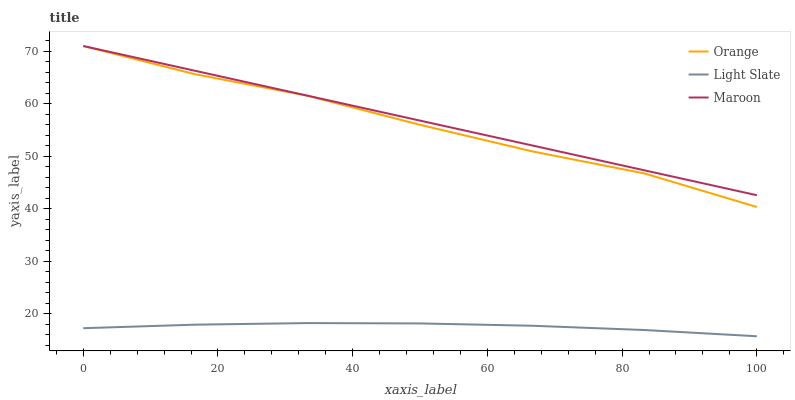Does Light Slate have the minimum area under the curve?
Answer yes or no. Yes. Does Maroon have the minimum area under the curve?
Answer yes or no. No. Does Light Slate have the maximum area under the curve?
Answer yes or no. No. Is Orange the roughest?
Answer yes or no. Yes. Is Light Slate the smoothest?
Answer yes or no. No. Is Light Slate the roughest?
Answer yes or no. No. Does Maroon have the lowest value?
Answer yes or no. No. Does Light Slate have the highest value?
Answer yes or no. No. Is Light Slate less than Orange?
Answer yes or no. Yes. Is Orange greater than Light Slate?
Answer yes or no. Yes. Does Light Slate intersect Orange?
Answer yes or no. No. 